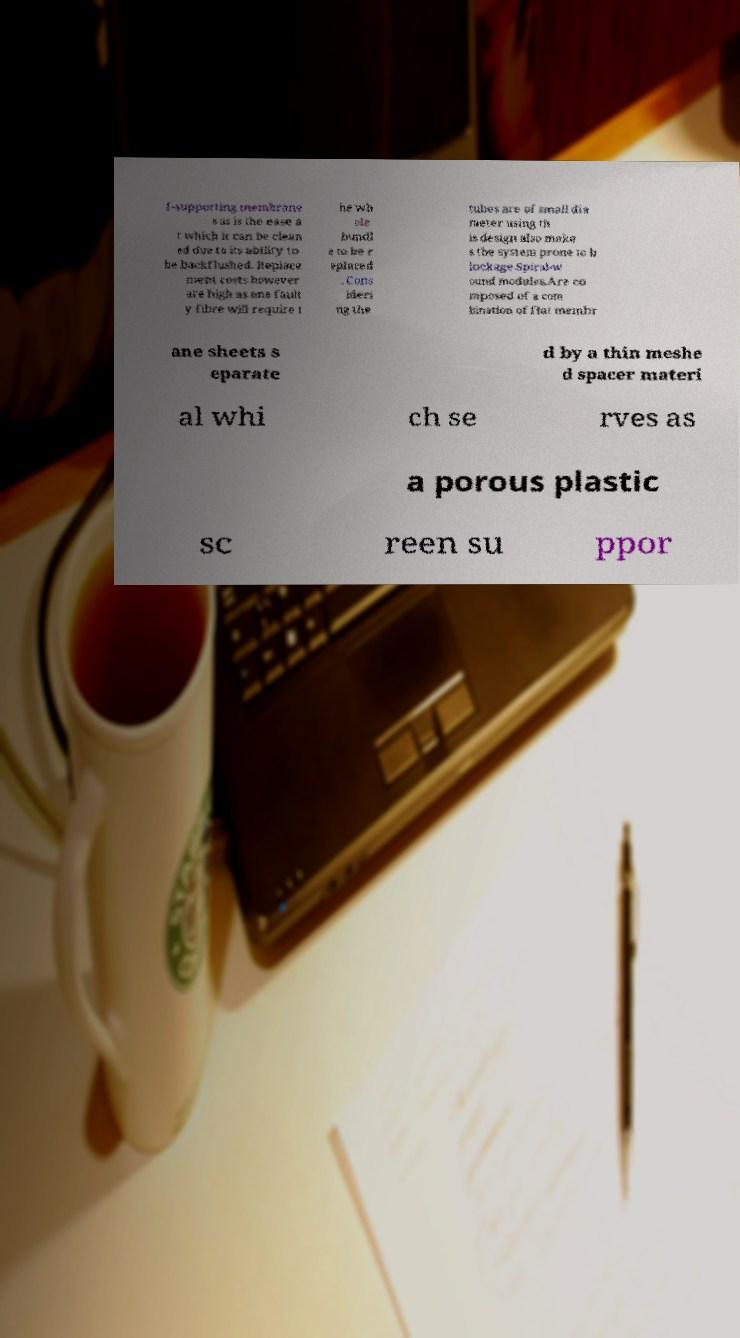What messages or text are displayed in this image? I need them in a readable, typed format. f-supporting membrane s as is the ease a t which it can be clean ed due to its ability to be backflushed. Replace ment costs however are high as one fault y fibre will require t he wh ole bundl e to be r eplaced . Cons ideri ng the tubes are of small dia meter using th is design also make s the system prone to b lockage.Spiral-w ound modules.Are co mposed of a com bination of flat membr ane sheets s eparate d by a thin meshe d spacer materi al whi ch se rves as a porous plastic sc reen su ppor 